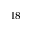Convert formula to latex. <formula><loc_0><loc_0><loc_500><loc_500>^ { 1 8 }</formula> 